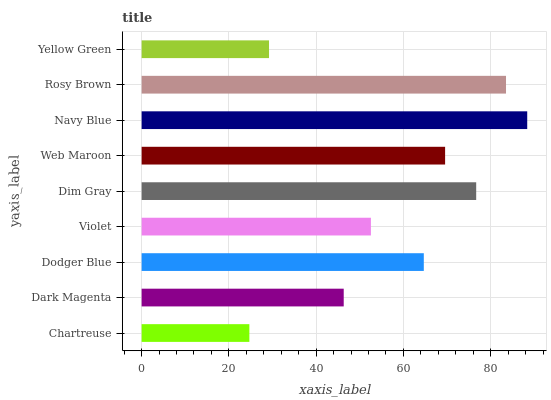Is Chartreuse the minimum?
Answer yes or no. Yes. Is Navy Blue the maximum?
Answer yes or no. Yes. Is Dark Magenta the minimum?
Answer yes or no. No. Is Dark Magenta the maximum?
Answer yes or no. No. Is Dark Magenta greater than Chartreuse?
Answer yes or no. Yes. Is Chartreuse less than Dark Magenta?
Answer yes or no. Yes. Is Chartreuse greater than Dark Magenta?
Answer yes or no. No. Is Dark Magenta less than Chartreuse?
Answer yes or no. No. Is Dodger Blue the high median?
Answer yes or no. Yes. Is Dodger Blue the low median?
Answer yes or no. Yes. Is Rosy Brown the high median?
Answer yes or no. No. Is Violet the low median?
Answer yes or no. No. 